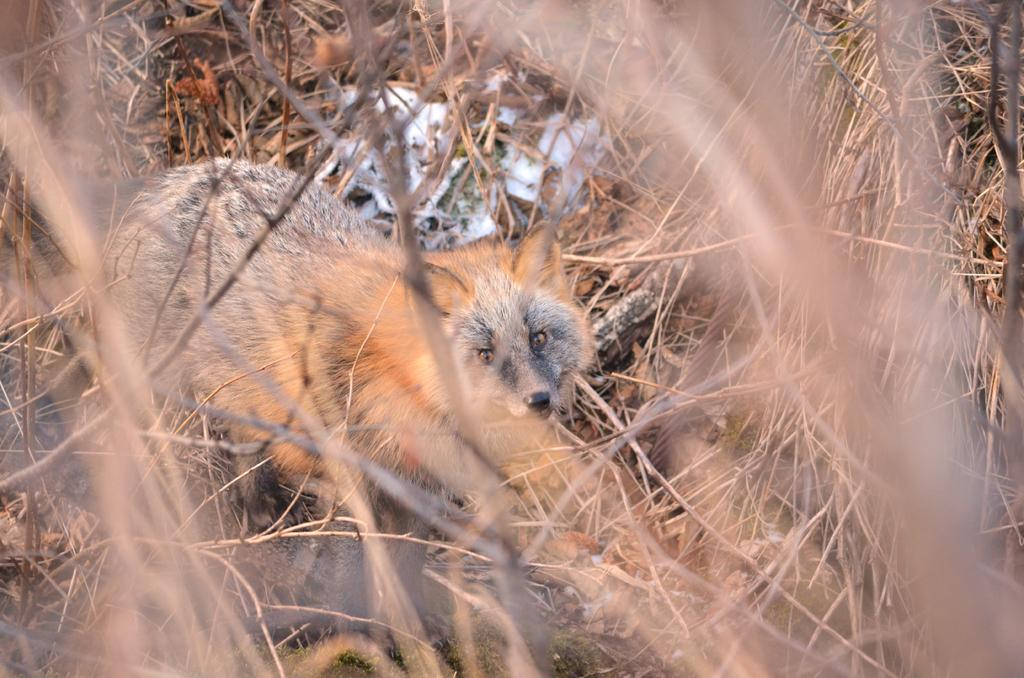What type of vegetation is present in the front of the image? There is dry grass in the front of the image. What is the main subject in the center of the image? There is an animal in the center of the image. Can you describe the white object on the grass? There is a white object on the grass, but its specific nature is not clear from the provided facts. How does the frog participate in the competition in the image? There is no frog or competition present in the image. What type of fan is visible in the image? There is no fan present in the image. 